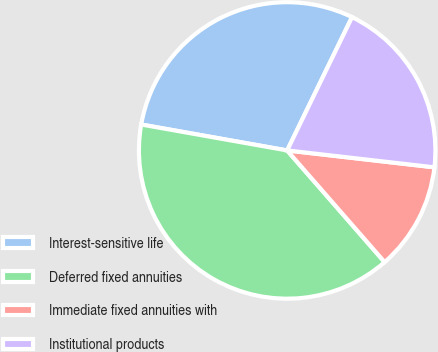<chart> <loc_0><loc_0><loc_500><loc_500><pie_chart><fcel>Interest-sensitive life<fcel>Deferred fixed annuities<fcel>Immediate fixed annuities with<fcel>Institutional products<nl><fcel>29.41%<fcel>39.22%<fcel>11.76%<fcel>19.61%<nl></chart> 